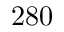Convert formula to latex. <formula><loc_0><loc_0><loc_500><loc_500>2 8 0</formula> 